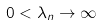<formula> <loc_0><loc_0><loc_500><loc_500>0 < \lambda _ { n } \to \infty</formula> 